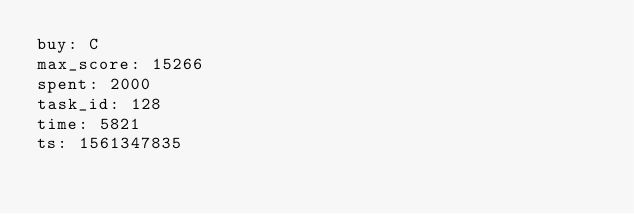<code> <loc_0><loc_0><loc_500><loc_500><_YAML_>buy: C
max_score: 15266
spent: 2000
task_id: 128
time: 5821
ts: 1561347835
</code> 